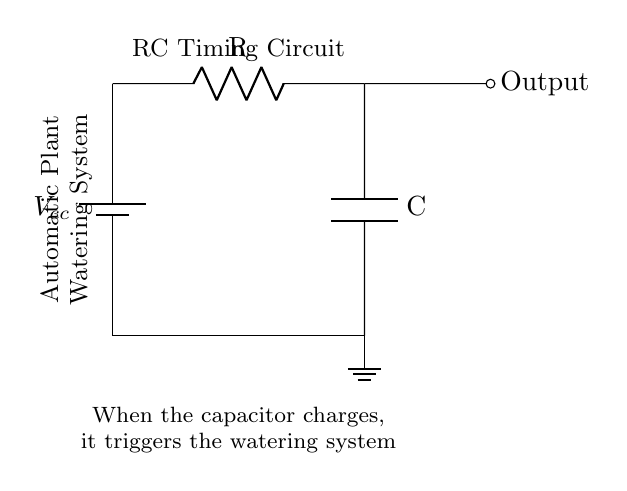What components are present in this circuit? The components visible in the circuit are a battery, resistor, capacitor, and ground connection. They are essential for the function of the automatic plant watering system.
Answer: Battery, resistor, capacitor, ground What does the capacitor do in this circuit? The capacitor stores electrical energy and, when charged, triggers the watering system to operate. This is indicated in the explanatory text within the diagram.
Answer: Triggers watering system What type of circuit is shown in the diagram? The circuit is an RC timing circuit, which consists of a resistor and a capacitor used for timing applications in this context.
Answer: RC timing circuit How is the watering system activated? The watering system is activated when the capacitor charges, which indicates a change in voltage level needed to operate the system. This triggers the mechanism to start watering.
Answer: When capacitor charges What role does the resistor play in this circuit? The resistor limits the charging current to the capacitor, thereby controlling the charging rate and affecting the timing of the circuit. This is crucial for the timing aspect, as it determines how long it takes for the capacitor to charge to a specific voltage.
Answer: Limits charging current What is the supply voltage indicated in the circuit? The supply voltage, represented by the symbol "Vcc" next to the battery, is the source voltage for this circuit but is not explicitly stated in the diagram. It typically needs to be defined based on the application using the circuit.
Answer: Vcc (source voltage) 